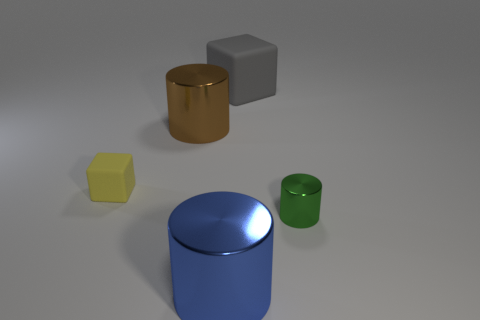How many other things are there of the same color as the small shiny cylinder?
Ensure brevity in your answer.  0. The small thing on the right side of the rubber cube that is to the right of the brown thing is what color?
Offer a very short reply. Green. Are there any tiny spheres that have the same color as the small rubber object?
Ensure brevity in your answer.  No. How many metallic objects are big blue objects or small cyan things?
Offer a terse response. 1. Are there any large yellow things made of the same material as the big cube?
Your answer should be very brief. No. What number of things are behind the tiny matte object and in front of the tiny yellow rubber object?
Your answer should be very brief. 0. Is the number of big brown metallic cylinders behind the gray matte cube less than the number of brown cylinders in front of the yellow block?
Your answer should be very brief. No. Is the yellow object the same shape as the large gray object?
Provide a succinct answer. Yes. What number of other things are there of the same size as the yellow matte cube?
Your answer should be compact. 1. How many things are either large metal cylinders in front of the green metallic object or metallic cylinders that are to the left of the large matte cube?
Your response must be concise. 2. 